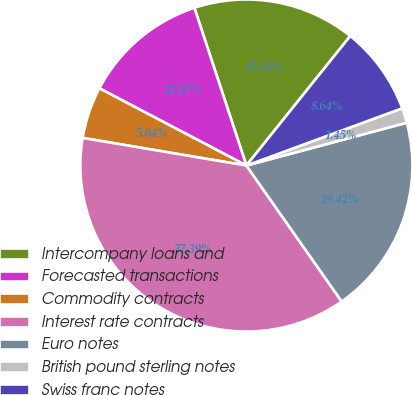Convert chart. <chart><loc_0><loc_0><loc_500><loc_500><pie_chart><fcel>Intercompany loans and<fcel>Forecasted transactions<fcel>Commodity contracts<fcel>Interest rate contracts<fcel>Euro notes<fcel>British pound sterling notes<fcel>Swiss franc notes<nl><fcel>15.83%<fcel>12.23%<fcel>5.04%<fcel>37.39%<fcel>19.42%<fcel>1.45%<fcel>8.64%<nl></chart> 